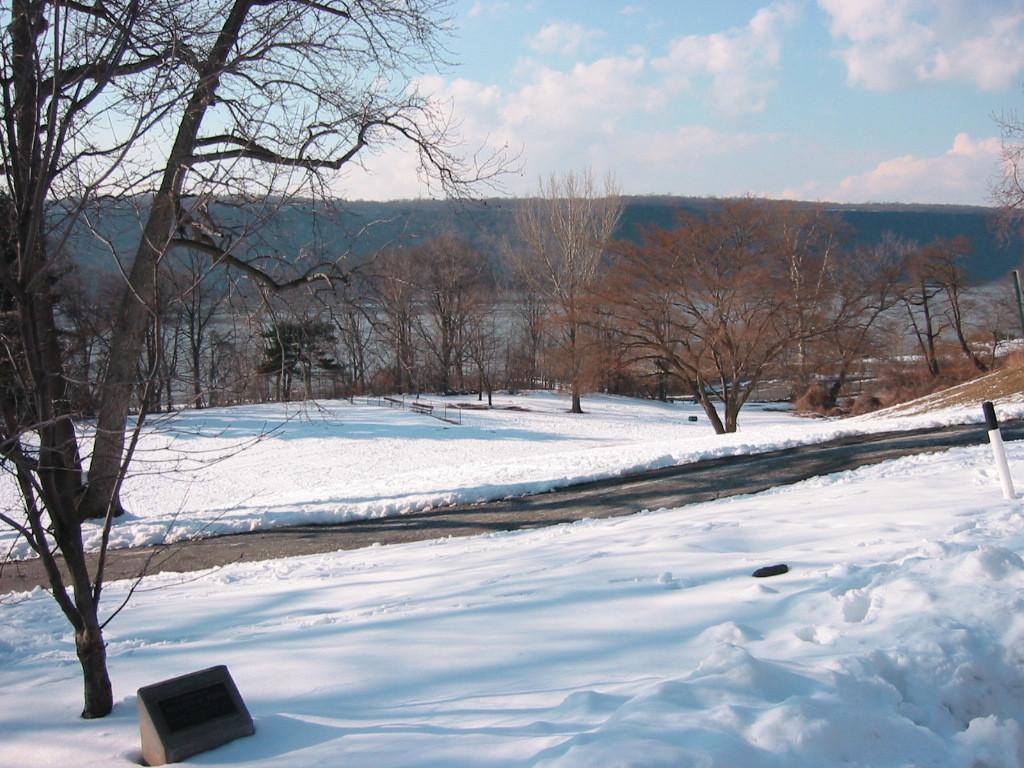Please provide a concise description of this image. In this image in the front there is snow on the ground and there is a dry tree. In the background there are trees, mountains and the sky is cloudy. 